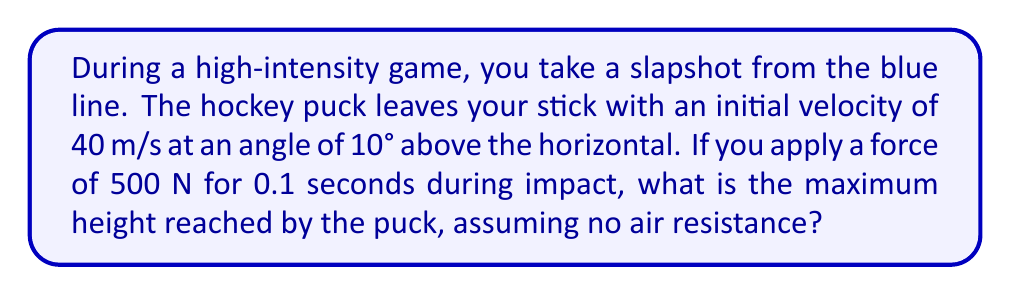Can you solve this math problem? Let's approach this step-by-step:

1) First, we need to calculate the initial vertical and horizontal velocity components:
   
   $v_{x0} = v_0 \cos(\theta) = 40 \cos(10°) = 39.39$ m/s
   $v_{y0} = v_0 \sin(\theta) = 40 \sin(10°) = 6.95$ m/s

2) The force applied during impact will change the velocity. We can calculate this change using the impulse-momentum theorem:
   
   $\Delta v = \frac{F \Delta t}{m}$

   Where $m$ is the mass of a hockey puck, typically about 0.17 kg.

   $\Delta v = \frac{500 \times 0.1}{0.17} = 294.12$ m/s

3) This change in velocity is primarily in the direction of the stick, which we'll assume is the same as the initial velocity direction. So we need to update our initial velocities:

   $v_{x0}' = v_{x0} + \Delta v \cos(10°) = 39.39 + 294.12 \cos(10°) = 328.98$ m/s
   $v_{y0}' = v_{y0} + \Delta v \sin(10°) = 6.95 + 294.12 \sin(10°) = 58.01$ m/s

4) To find the maximum height, we use the equation:

   $h_{max} = \frac{(v_{y0}')^2}{2g}$

   Where $g$ is the acceleration due to gravity (9.8 m/s²).

5) Plugging in our values:

   $h_{max} = \frac{(58.01)^2}{2(9.8)} = 171.72$ m

Therefore, the maximum height reached by the puck is approximately 171.72 meters.
Answer: 171.72 m 